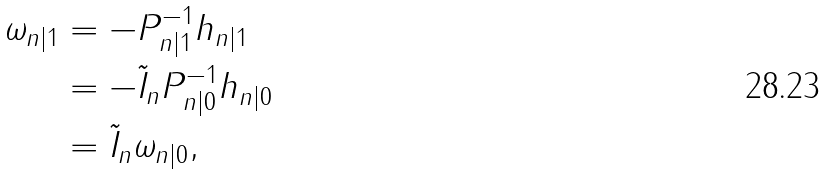Convert formula to latex. <formula><loc_0><loc_0><loc_500><loc_500>\omega _ { n | 1 } & = - P _ { n | 1 } ^ { - 1 } h _ { n | 1 } \\ & = - \tilde { I } _ { n } P _ { n | 0 } ^ { - 1 } h _ { n | 0 } \\ & = \tilde { I } _ { n } \omega _ { n | 0 } ,</formula> 